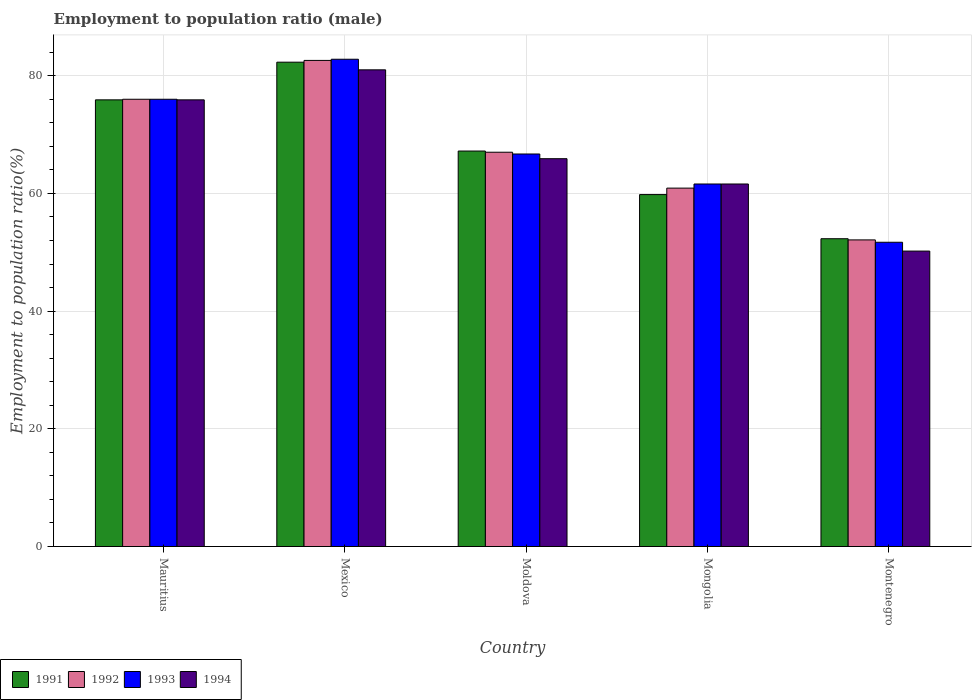How many groups of bars are there?
Provide a short and direct response. 5. What is the label of the 5th group of bars from the left?
Provide a short and direct response. Montenegro. In how many cases, is the number of bars for a given country not equal to the number of legend labels?
Ensure brevity in your answer.  0. What is the employment to population ratio in 1992 in Mongolia?
Your answer should be very brief. 60.9. Across all countries, what is the maximum employment to population ratio in 1994?
Your response must be concise. 81. Across all countries, what is the minimum employment to population ratio in 1994?
Provide a succinct answer. 50.2. In which country was the employment to population ratio in 1993 minimum?
Keep it short and to the point. Montenegro. What is the total employment to population ratio in 1993 in the graph?
Provide a succinct answer. 338.8. What is the difference between the employment to population ratio in 1994 in Mauritius and that in Mongolia?
Offer a terse response. 14.3. What is the difference between the employment to population ratio in 1994 in Montenegro and the employment to population ratio in 1992 in Mongolia?
Keep it short and to the point. -10.7. What is the average employment to population ratio in 1994 per country?
Your response must be concise. 66.92. What is the difference between the employment to population ratio of/in 1991 and employment to population ratio of/in 1993 in Moldova?
Make the answer very short. 0.5. What is the ratio of the employment to population ratio in 1994 in Mauritius to that in Moldova?
Offer a terse response. 1.15. What is the difference between the highest and the second highest employment to population ratio in 1992?
Keep it short and to the point. 15.6. What is the difference between the highest and the lowest employment to population ratio in 1993?
Make the answer very short. 31.1. What does the 1st bar from the right in Mongolia represents?
Provide a short and direct response. 1994. Is it the case that in every country, the sum of the employment to population ratio in 1994 and employment to population ratio in 1993 is greater than the employment to population ratio in 1992?
Give a very brief answer. Yes. Are all the bars in the graph horizontal?
Keep it short and to the point. No. How many countries are there in the graph?
Your response must be concise. 5. What is the difference between two consecutive major ticks on the Y-axis?
Keep it short and to the point. 20. What is the title of the graph?
Your response must be concise. Employment to population ratio (male). Does "1999" appear as one of the legend labels in the graph?
Provide a succinct answer. No. What is the label or title of the X-axis?
Offer a very short reply. Country. What is the label or title of the Y-axis?
Ensure brevity in your answer.  Employment to population ratio(%). What is the Employment to population ratio(%) in 1991 in Mauritius?
Your response must be concise. 75.9. What is the Employment to population ratio(%) in 1992 in Mauritius?
Give a very brief answer. 76. What is the Employment to population ratio(%) in 1993 in Mauritius?
Offer a very short reply. 76. What is the Employment to population ratio(%) in 1994 in Mauritius?
Give a very brief answer. 75.9. What is the Employment to population ratio(%) of 1991 in Mexico?
Your answer should be very brief. 82.3. What is the Employment to population ratio(%) of 1992 in Mexico?
Make the answer very short. 82.6. What is the Employment to population ratio(%) in 1993 in Mexico?
Provide a succinct answer. 82.8. What is the Employment to population ratio(%) in 1994 in Mexico?
Your response must be concise. 81. What is the Employment to population ratio(%) in 1991 in Moldova?
Offer a terse response. 67.2. What is the Employment to population ratio(%) of 1993 in Moldova?
Keep it short and to the point. 66.7. What is the Employment to population ratio(%) in 1994 in Moldova?
Provide a short and direct response. 65.9. What is the Employment to population ratio(%) in 1991 in Mongolia?
Ensure brevity in your answer.  59.8. What is the Employment to population ratio(%) of 1992 in Mongolia?
Your answer should be very brief. 60.9. What is the Employment to population ratio(%) of 1993 in Mongolia?
Keep it short and to the point. 61.6. What is the Employment to population ratio(%) in 1994 in Mongolia?
Make the answer very short. 61.6. What is the Employment to population ratio(%) in 1991 in Montenegro?
Offer a terse response. 52.3. What is the Employment to population ratio(%) of 1992 in Montenegro?
Your answer should be very brief. 52.1. What is the Employment to population ratio(%) in 1993 in Montenegro?
Your answer should be compact. 51.7. What is the Employment to population ratio(%) of 1994 in Montenegro?
Offer a terse response. 50.2. Across all countries, what is the maximum Employment to population ratio(%) in 1991?
Your answer should be very brief. 82.3. Across all countries, what is the maximum Employment to population ratio(%) in 1992?
Offer a terse response. 82.6. Across all countries, what is the maximum Employment to population ratio(%) of 1993?
Your answer should be very brief. 82.8. Across all countries, what is the minimum Employment to population ratio(%) in 1991?
Provide a succinct answer. 52.3. Across all countries, what is the minimum Employment to population ratio(%) of 1992?
Give a very brief answer. 52.1. Across all countries, what is the minimum Employment to population ratio(%) of 1993?
Provide a succinct answer. 51.7. Across all countries, what is the minimum Employment to population ratio(%) in 1994?
Your answer should be compact. 50.2. What is the total Employment to population ratio(%) in 1991 in the graph?
Provide a succinct answer. 337.5. What is the total Employment to population ratio(%) in 1992 in the graph?
Keep it short and to the point. 338.6. What is the total Employment to population ratio(%) in 1993 in the graph?
Provide a succinct answer. 338.8. What is the total Employment to population ratio(%) in 1994 in the graph?
Offer a very short reply. 334.6. What is the difference between the Employment to population ratio(%) in 1992 in Mauritius and that in Mexico?
Offer a very short reply. -6.6. What is the difference between the Employment to population ratio(%) of 1993 in Mauritius and that in Mexico?
Keep it short and to the point. -6.8. What is the difference between the Employment to population ratio(%) of 1994 in Mauritius and that in Mexico?
Keep it short and to the point. -5.1. What is the difference between the Employment to population ratio(%) in 1991 in Mauritius and that in Moldova?
Give a very brief answer. 8.7. What is the difference between the Employment to population ratio(%) of 1992 in Mauritius and that in Moldova?
Your answer should be compact. 9. What is the difference between the Employment to population ratio(%) of 1991 in Mauritius and that in Mongolia?
Your answer should be compact. 16.1. What is the difference between the Employment to population ratio(%) in 1992 in Mauritius and that in Mongolia?
Provide a succinct answer. 15.1. What is the difference between the Employment to population ratio(%) in 1994 in Mauritius and that in Mongolia?
Provide a short and direct response. 14.3. What is the difference between the Employment to population ratio(%) in 1991 in Mauritius and that in Montenegro?
Make the answer very short. 23.6. What is the difference between the Employment to population ratio(%) of 1992 in Mauritius and that in Montenegro?
Your response must be concise. 23.9. What is the difference between the Employment to population ratio(%) of 1993 in Mauritius and that in Montenegro?
Make the answer very short. 24.3. What is the difference between the Employment to population ratio(%) of 1994 in Mauritius and that in Montenegro?
Provide a short and direct response. 25.7. What is the difference between the Employment to population ratio(%) in 1994 in Mexico and that in Moldova?
Your answer should be compact. 15.1. What is the difference between the Employment to population ratio(%) in 1992 in Mexico and that in Mongolia?
Give a very brief answer. 21.7. What is the difference between the Employment to population ratio(%) of 1993 in Mexico and that in Mongolia?
Your response must be concise. 21.2. What is the difference between the Employment to population ratio(%) in 1994 in Mexico and that in Mongolia?
Your answer should be very brief. 19.4. What is the difference between the Employment to population ratio(%) of 1992 in Mexico and that in Montenegro?
Offer a very short reply. 30.5. What is the difference between the Employment to population ratio(%) of 1993 in Mexico and that in Montenegro?
Your answer should be compact. 31.1. What is the difference between the Employment to population ratio(%) in 1994 in Mexico and that in Montenegro?
Offer a terse response. 30.8. What is the difference between the Employment to population ratio(%) of 1991 in Moldova and that in Mongolia?
Your response must be concise. 7.4. What is the difference between the Employment to population ratio(%) of 1993 in Moldova and that in Mongolia?
Your response must be concise. 5.1. What is the difference between the Employment to population ratio(%) of 1992 in Moldova and that in Montenegro?
Give a very brief answer. 14.9. What is the difference between the Employment to population ratio(%) of 1994 in Moldova and that in Montenegro?
Make the answer very short. 15.7. What is the difference between the Employment to population ratio(%) of 1994 in Mongolia and that in Montenegro?
Offer a terse response. 11.4. What is the difference between the Employment to population ratio(%) in 1991 in Mauritius and the Employment to population ratio(%) in 1992 in Mexico?
Keep it short and to the point. -6.7. What is the difference between the Employment to population ratio(%) of 1991 in Mauritius and the Employment to population ratio(%) of 1993 in Mexico?
Keep it short and to the point. -6.9. What is the difference between the Employment to population ratio(%) in 1991 in Mauritius and the Employment to population ratio(%) in 1994 in Moldova?
Keep it short and to the point. 10. What is the difference between the Employment to population ratio(%) in 1992 in Mauritius and the Employment to population ratio(%) in 1994 in Moldova?
Keep it short and to the point. 10.1. What is the difference between the Employment to population ratio(%) in 1993 in Mauritius and the Employment to population ratio(%) in 1994 in Moldova?
Keep it short and to the point. 10.1. What is the difference between the Employment to population ratio(%) in 1991 in Mauritius and the Employment to population ratio(%) in 1994 in Mongolia?
Provide a short and direct response. 14.3. What is the difference between the Employment to population ratio(%) of 1992 in Mauritius and the Employment to population ratio(%) of 1993 in Mongolia?
Provide a short and direct response. 14.4. What is the difference between the Employment to population ratio(%) of 1993 in Mauritius and the Employment to population ratio(%) of 1994 in Mongolia?
Make the answer very short. 14.4. What is the difference between the Employment to population ratio(%) in 1991 in Mauritius and the Employment to population ratio(%) in 1992 in Montenegro?
Your answer should be compact. 23.8. What is the difference between the Employment to population ratio(%) in 1991 in Mauritius and the Employment to population ratio(%) in 1993 in Montenegro?
Provide a succinct answer. 24.2. What is the difference between the Employment to population ratio(%) in 1991 in Mauritius and the Employment to population ratio(%) in 1994 in Montenegro?
Keep it short and to the point. 25.7. What is the difference between the Employment to population ratio(%) in 1992 in Mauritius and the Employment to population ratio(%) in 1993 in Montenegro?
Give a very brief answer. 24.3. What is the difference between the Employment to population ratio(%) in 1992 in Mauritius and the Employment to population ratio(%) in 1994 in Montenegro?
Your answer should be compact. 25.8. What is the difference between the Employment to population ratio(%) in 1993 in Mauritius and the Employment to population ratio(%) in 1994 in Montenegro?
Provide a succinct answer. 25.8. What is the difference between the Employment to population ratio(%) of 1991 in Mexico and the Employment to population ratio(%) of 1994 in Moldova?
Your response must be concise. 16.4. What is the difference between the Employment to population ratio(%) of 1992 in Mexico and the Employment to population ratio(%) of 1994 in Moldova?
Ensure brevity in your answer.  16.7. What is the difference between the Employment to population ratio(%) of 1993 in Mexico and the Employment to population ratio(%) of 1994 in Moldova?
Your response must be concise. 16.9. What is the difference between the Employment to population ratio(%) in 1991 in Mexico and the Employment to population ratio(%) in 1992 in Mongolia?
Your answer should be very brief. 21.4. What is the difference between the Employment to population ratio(%) in 1991 in Mexico and the Employment to population ratio(%) in 1993 in Mongolia?
Make the answer very short. 20.7. What is the difference between the Employment to population ratio(%) in 1991 in Mexico and the Employment to population ratio(%) in 1994 in Mongolia?
Give a very brief answer. 20.7. What is the difference between the Employment to population ratio(%) in 1992 in Mexico and the Employment to population ratio(%) in 1993 in Mongolia?
Your answer should be very brief. 21. What is the difference between the Employment to population ratio(%) of 1993 in Mexico and the Employment to population ratio(%) of 1994 in Mongolia?
Provide a succinct answer. 21.2. What is the difference between the Employment to population ratio(%) in 1991 in Mexico and the Employment to population ratio(%) in 1992 in Montenegro?
Keep it short and to the point. 30.2. What is the difference between the Employment to population ratio(%) in 1991 in Mexico and the Employment to population ratio(%) in 1993 in Montenegro?
Make the answer very short. 30.6. What is the difference between the Employment to population ratio(%) in 1991 in Mexico and the Employment to population ratio(%) in 1994 in Montenegro?
Offer a very short reply. 32.1. What is the difference between the Employment to population ratio(%) of 1992 in Mexico and the Employment to population ratio(%) of 1993 in Montenegro?
Your answer should be very brief. 30.9. What is the difference between the Employment to population ratio(%) in 1992 in Mexico and the Employment to population ratio(%) in 1994 in Montenegro?
Ensure brevity in your answer.  32.4. What is the difference between the Employment to population ratio(%) in 1993 in Mexico and the Employment to population ratio(%) in 1994 in Montenegro?
Ensure brevity in your answer.  32.6. What is the difference between the Employment to population ratio(%) in 1991 in Moldova and the Employment to population ratio(%) in 1992 in Mongolia?
Give a very brief answer. 6.3. What is the difference between the Employment to population ratio(%) of 1991 in Moldova and the Employment to population ratio(%) of 1994 in Mongolia?
Provide a short and direct response. 5.6. What is the difference between the Employment to population ratio(%) in 1992 in Moldova and the Employment to population ratio(%) in 1993 in Mongolia?
Provide a short and direct response. 5.4. What is the difference between the Employment to population ratio(%) in 1992 in Moldova and the Employment to population ratio(%) in 1994 in Mongolia?
Ensure brevity in your answer.  5.4. What is the difference between the Employment to population ratio(%) of 1991 in Moldova and the Employment to population ratio(%) of 1992 in Montenegro?
Keep it short and to the point. 15.1. What is the difference between the Employment to population ratio(%) of 1992 in Moldova and the Employment to population ratio(%) of 1994 in Montenegro?
Give a very brief answer. 16.8. What is the difference between the Employment to population ratio(%) of 1993 in Moldova and the Employment to population ratio(%) of 1994 in Montenegro?
Provide a succinct answer. 16.5. What is the difference between the Employment to population ratio(%) of 1991 in Mongolia and the Employment to population ratio(%) of 1993 in Montenegro?
Your response must be concise. 8.1. What is the difference between the Employment to population ratio(%) of 1992 in Mongolia and the Employment to population ratio(%) of 1994 in Montenegro?
Offer a very short reply. 10.7. What is the difference between the Employment to population ratio(%) in 1993 in Mongolia and the Employment to population ratio(%) in 1994 in Montenegro?
Ensure brevity in your answer.  11.4. What is the average Employment to population ratio(%) of 1991 per country?
Provide a succinct answer. 67.5. What is the average Employment to population ratio(%) of 1992 per country?
Offer a terse response. 67.72. What is the average Employment to population ratio(%) in 1993 per country?
Provide a succinct answer. 67.76. What is the average Employment to population ratio(%) of 1994 per country?
Your response must be concise. 66.92. What is the difference between the Employment to population ratio(%) in 1991 and Employment to population ratio(%) in 1994 in Mauritius?
Provide a succinct answer. 0. What is the difference between the Employment to population ratio(%) in 1992 and Employment to population ratio(%) in 1993 in Mauritius?
Provide a short and direct response. 0. What is the difference between the Employment to population ratio(%) of 1993 and Employment to population ratio(%) of 1994 in Mauritius?
Make the answer very short. 0.1. What is the difference between the Employment to population ratio(%) of 1992 and Employment to population ratio(%) of 1993 in Mexico?
Ensure brevity in your answer.  -0.2. What is the difference between the Employment to population ratio(%) in 1992 and Employment to population ratio(%) in 1994 in Mexico?
Your response must be concise. 1.6. What is the difference between the Employment to population ratio(%) of 1991 and Employment to population ratio(%) of 1992 in Moldova?
Your answer should be compact. 0.2. What is the difference between the Employment to population ratio(%) in 1991 and Employment to population ratio(%) in 1993 in Moldova?
Offer a very short reply. 0.5. What is the difference between the Employment to population ratio(%) of 1992 and Employment to population ratio(%) of 1994 in Moldova?
Ensure brevity in your answer.  1.1. What is the difference between the Employment to population ratio(%) in 1993 and Employment to population ratio(%) in 1994 in Moldova?
Make the answer very short. 0.8. What is the difference between the Employment to population ratio(%) in 1991 and Employment to population ratio(%) in 1992 in Mongolia?
Provide a short and direct response. -1.1. What is the difference between the Employment to population ratio(%) in 1991 and Employment to population ratio(%) in 1993 in Mongolia?
Your answer should be compact. -1.8. What is the difference between the Employment to population ratio(%) of 1991 and Employment to population ratio(%) of 1994 in Mongolia?
Give a very brief answer. -1.8. What is the difference between the Employment to population ratio(%) in 1992 and Employment to population ratio(%) in 1994 in Mongolia?
Ensure brevity in your answer.  -0.7. What is the difference between the Employment to population ratio(%) in 1991 and Employment to population ratio(%) in 1992 in Montenegro?
Ensure brevity in your answer.  0.2. What is the difference between the Employment to population ratio(%) in 1991 and Employment to population ratio(%) in 1993 in Montenegro?
Offer a terse response. 0.6. What is the difference between the Employment to population ratio(%) in 1991 and Employment to population ratio(%) in 1994 in Montenegro?
Give a very brief answer. 2.1. What is the difference between the Employment to population ratio(%) of 1992 and Employment to population ratio(%) of 1993 in Montenegro?
Offer a very short reply. 0.4. What is the difference between the Employment to population ratio(%) in 1993 and Employment to population ratio(%) in 1994 in Montenegro?
Your response must be concise. 1.5. What is the ratio of the Employment to population ratio(%) in 1991 in Mauritius to that in Mexico?
Your answer should be compact. 0.92. What is the ratio of the Employment to population ratio(%) in 1992 in Mauritius to that in Mexico?
Make the answer very short. 0.92. What is the ratio of the Employment to population ratio(%) in 1993 in Mauritius to that in Mexico?
Your answer should be very brief. 0.92. What is the ratio of the Employment to population ratio(%) in 1994 in Mauritius to that in Mexico?
Offer a very short reply. 0.94. What is the ratio of the Employment to population ratio(%) of 1991 in Mauritius to that in Moldova?
Your answer should be very brief. 1.13. What is the ratio of the Employment to population ratio(%) in 1992 in Mauritius to that in Moldova?
Your response must be concise. 1.13. What is the ratio of the Employment to population ratio(%) in 1993 in Mauritius to that in Moldova?
Make the answer very short. 1.14. What is the ratio of the Employment to population ratio(%) in 1994 in Mauritius to that in Moldova?
Your response must be concise. 1.15. What is the ratio of the Employment to population ratio(%) of 1991 in Mauritius to that in Mongolia?
Offer a very short reply. 1.27. What is the ratio of the Employment to population ratio(%) in 1992 in Mauritius to that in Mongolia?
Your answer should be compact. 1.25. What is the ratio of the Employment to population ratio(%) in 1993 in Mauritius to that in Mongolia?
Give a very brief answer. 1.23. What is the ratio of the Employment to population ratio(%) of 1994 in Mauritius to that in Mongolia?
Keep it short and to the point. 1.23. What is the ratio of the Employment to population ratio(%) in 1991 in Mauritius to that in Montenegro?
Make the answer very short. 1.45. What is the ratio of the Employment to population ratio(%) of 1992 in Mauritius to that in Montenegro?
Give a very brief answer. 1.46. What is the ratio of the Employment to population ratio(%) in 1993 in Mauritius to that in Montenegro?
Offer a very short reply. 1.47. What is the ratio of the Employment to population ratio(%) in 1994 in Mauritius to that in Montenegro?
Your answer should be compact. 1.51. What is the ratio of the Employment to population ratio(%) of 1991 in Mexico to that in Moldova?
Make the answer very short. 1.22. What is the ratio of the Employment to population ratio(%) in 1992 in Mexico to that in Moldova?
Offer a terse response. 1.23. What is the ratio of the Employment to population ratio(%) in 1993 in Mexico to that in Moldova?
Ensure brevity in your answer.  1.24. What is the ratio of the Employment to population ratio(%) of 1994 in Mexico to that in Moldova?
Make the answer very short. 1.23. What is the ratio of the Employment to population ratio(%) of 1991 in Mexico to that in Mongolia?
Your response must be concise. 1.38. What is the ratio of the Employment to population ratio(%) of 1992 in Mexico to that in Mongolia?
Keep it short and to the point. 1.36. What is the ratio of the Employment to population ratio(%) of 1993 in Mexico to that in Mongolia?
Offer a very short reply. 1.34. What is the ratio of the Employment to population ratio(%) of 1994 in Mexico to that in Mongolia?
Make the answer very short. 1.31. What is the ratio of the Employment to population ratio(%) of 1991 in Mexico to that in Montenegro?
Make the answer very short. 1.57. What is the ratio of the Employment to population ratio(%) in 1992 in Mexico to that in Montenegro?
Provide a short and direct response. 1.59. What is the ratio of the Employment to population ratio(%) of 1993 in Mexico to that in Montenegro?
Your answer should be very brief. 1.6. What is the ratio of the Employment to population ratio(%) in 1994 in Mexico to that in Montenegro?
Your response must be concise. 1.61. What is the ratio of the Employment to population ratio(%) of 1991 in Moldova to that in Mongolia?
Your answer should be compact. 1.12. What is the ratio of the Employment to population ratio(%) in 1992 in Moldova to that in Mongolia?
Keep it short and to the point. 1.1. What is the ratio of the Employment to population ratio(%) of 1993 in Moldova to that in Mongolia?
Provide a succinct answer. 1.08. What is the ratio of the Employment to population ratio(%) in 1994 in Moldova to that in Mongolia?
Give a very brief answer. 1.07. What is the ratio of the Employment to population ratio(%) of 1991 in Moldova to that in Montenegro?
Keep it short and to the point. 1.28. What is the ratio of the Employment to population ratio(%) of 1992 in Moldova to that in Montenegro?
Offer a terse response. 1.29. What is the ratio of the Employment to population ratio(%) of 1993 in Moldova to that in Montenegro?
Keep it short and to the point. 1.29. What is the ratio of the Employment to population ratio(%) in 1994 in Moldova to that in Montenegro?
Provide a short and direct response. 1.31. What is the ratio of the Employment to population ratio(%) in 1991 in Mongolia to that in Montenegro?
Your response must be concise. 1.14. What is the ratio of the Employment to population ratio(%) in 1992 in Mongolia to that in Montenegro?
Ensure brevity in your answer.  1.17. What is the ratio of the Employment to population ratio(%) of 1993 in Mongolia to that in Montenegro?
Offer a terse response. 1.19. What is the ratio of the Employment to population ratio(%) of 1994 in Mongolia to that in Montenegro?
Keep it short and to the point. 1.23. What is the difference between the highest and the second highest Employment to population ratio(%) in 1994?
Your answer should be very brief. 5.1. What is the difference between the highest and the lowest Employment to population ratio(%) in 1991?
Your answer should be compact. 30. What is the difference between the highest and the lowest Employment to population ratio(%) of 1992?
Provide a succinct answer. 30.5. What is the difference between the highest and the lowest Employment to population ratio(%) of 1993?
Make the answer very short. 31.1. What is the difference between the highest and the lowest Employment to population ratio(%) in 1994?
Your answer should be very brief. 30.8. 